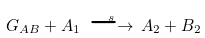<formula> <loc_0><loc_0><loc_500><loc_500>G _ { A B } + A _ { 1 } \overset { s } { \, \longrightarrow \, } A _ { 2 } + B _ { 2 }</formula> 